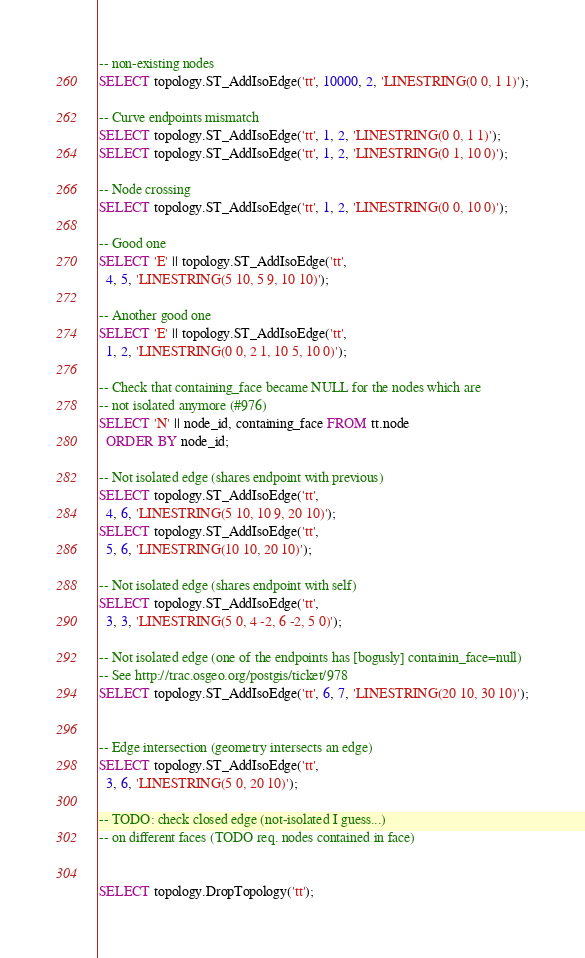Convert code to text. <code><loc_0><loc_0><loc_500><loc_500><_SQL_>
-- non-existing nodes
SELECT topology.ST_AddIsoEdge('tt', 10000, 2, 'LINESTRING(0 0, 1 1)');

-- Curve endpoints mismatch
SELECT topology.ST_AddIsoEdge('tt', 1, 2, 'LINESTRING(0 0, 1 1)');
SELECT topology.ST_AddIsoEdge('tt', 1, 2, 'LINESTRING(0 1, 10 0)');

-- Node crossing 
SELECT topology.ST_AddIsoEdge('tt', 1, 2, 'LINESTRING(0 0, 10 0)');

-- Good one
SELECT 'E' || topology.ST_AddIsoEdge('tt',
  4, 5, 'LINESTRING(5 10, 5 9, 10 10)');

-- Another good one
SELECT 'E' || topology.ST_AddIsoEdge('tt',
  1, 2, 'LINESTRING(0 0, 2 1, 10 5, 10 0)');

-- Check that containing_face became NULL for the nodes which are
-- not isolated anymore (#976)
SELECT 'N' || node_id, containing_face FROM tt.node
  ORDER BY node_id;

-- Not isolated edge (shares endpoint with previous)
SELECT topology.ST_AddIsoEdge('tt',
  4, 6, 'LINESTRING(5 10, 10 9, 20 10)');
SELECT topology.ST_AddIsoEdge('tt',
  5, 6, 'LINESTRING(10 10, 20 10)');

-- Not isolated edge (shares endpoint with self)
SELECT topology.ST_AddIsoEdge('tt',
  3, 3, 'LINESTRING(5 0, 4 -2, 6 -2, 5 0)');

-- Not isolated edge (one of the endpoints has [bogusly] containin_face=null)
-- See http://trac.osgeo.org/postgis/ticket/978
SELECT topology.ST_AddIsoEdge('tt', 6, 7, 'LINESTRING(20 10, 30 10)');


-- Edge intersection (geometry intersects an edge)
SELECT topology.ST_AddIsoEdge('tt',
  3, 6, 'LINESTRING(5 0, 20 10)');

-- TODO: check closed edge (not-isolated I guess...)
-- on different faces (TODO req. nodes contained in face)


SELECT topology.DropTopology('tt');
</code> 